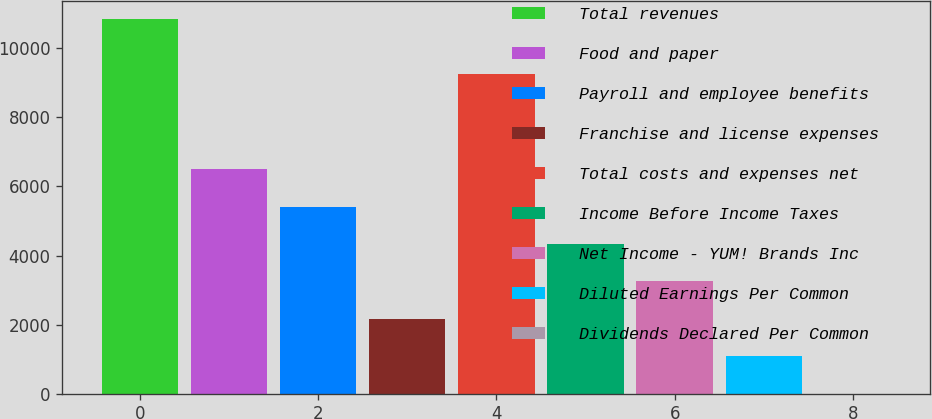Convert chart. <chart><loc_0><loc_0><loc_500><loc_500><bar_chart><fcel>Total revenues<fcel>Food and paper<fcel>Payroll and employee benefits<fcel>Franchise and license expenses<fcel>Total costs and expenses net<fcel>Income Before Income Taxes<fcel>Net Income - YUM! Brands Inc<fcel>Diluted Earnings Per Common<fcel>Dividends Declared Per Common<nl><fcel>10836<fcel>6501.92<fcel>5418.4<fcel>2167.84<fcel>9246<fcel>4334.88<fcel>3251.36<fcel>1084.32<fcel>0.8<nl></chart> 